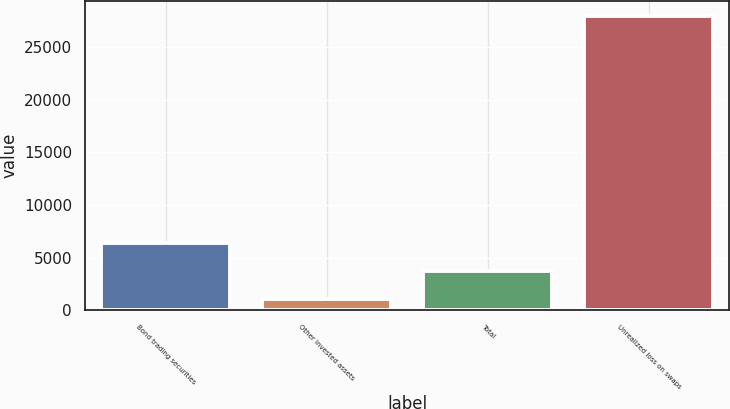Convert chart to OTSL. <chart><loc_0><loc_0><loc_500><loc_500><bar_chart><fcel>Bond trading securities<fcel>Other invested assets<fcel>Total<fcel>Unrealized loss on swaps<nl><fcel>6424.8<fcel>1042<fcel>3733.4<fcel>27956<nl></chart> 